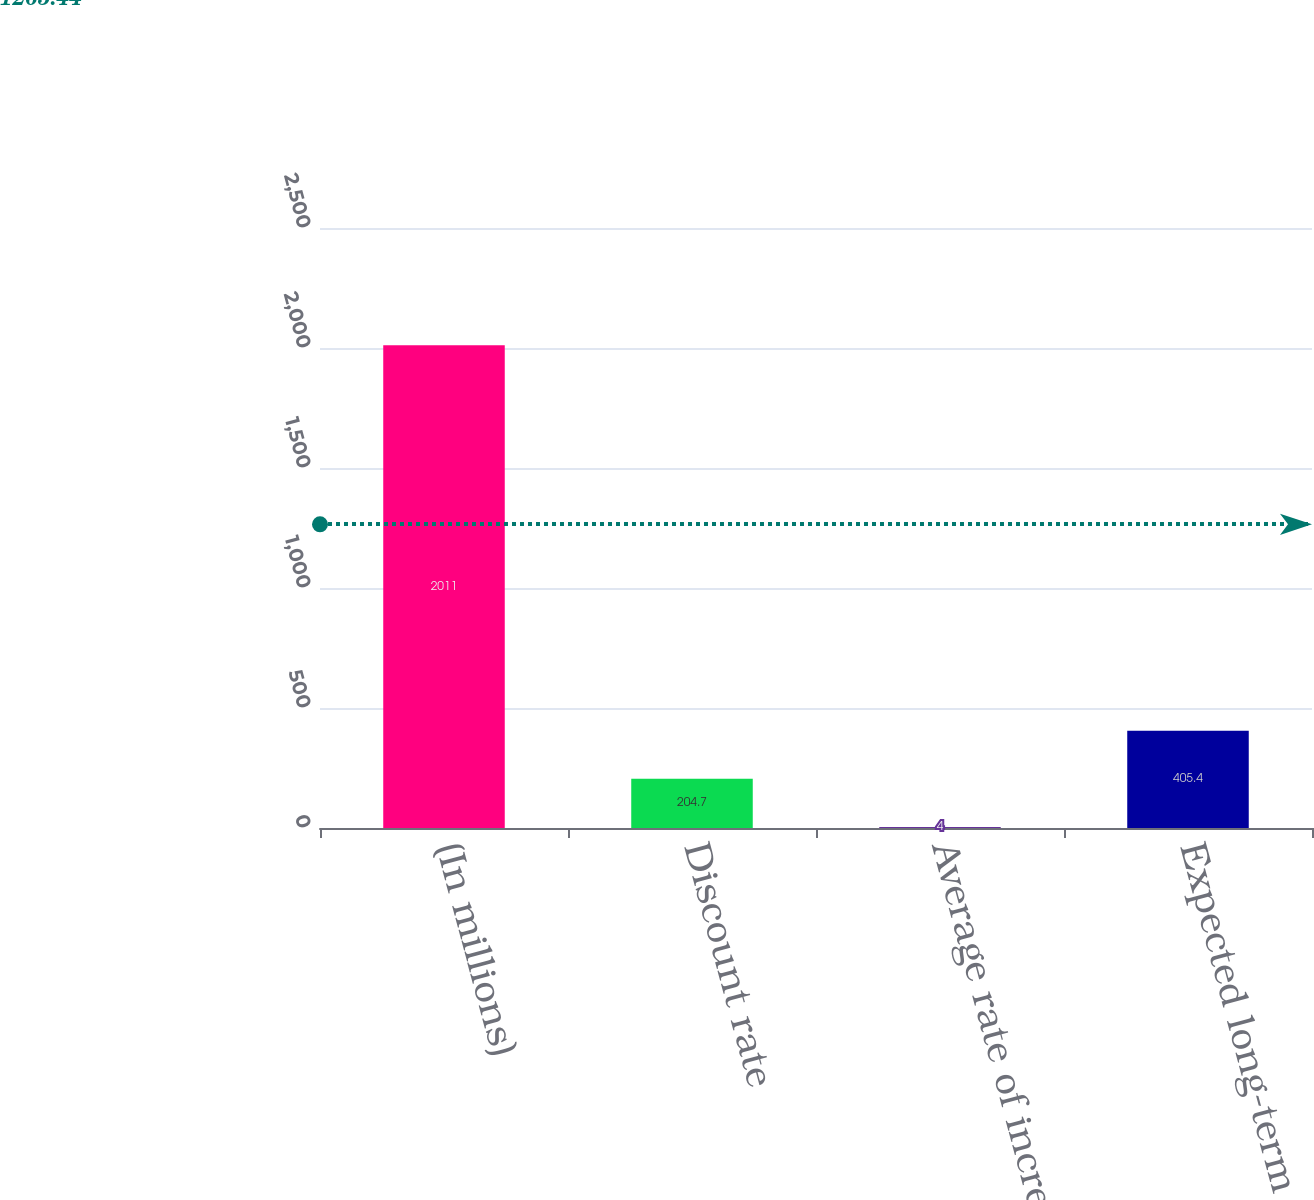<chart> <loc_0><loc_0><loc_500><loc_500><bar_chart><fcel>(In millions)<fcel>Discount rate<fcel>Average rate of increase in<fcel>Expected long-term rate of<nl><fcel>2011<fcel>204.7<fcel>4<fcel>405.4<nl></chart> 